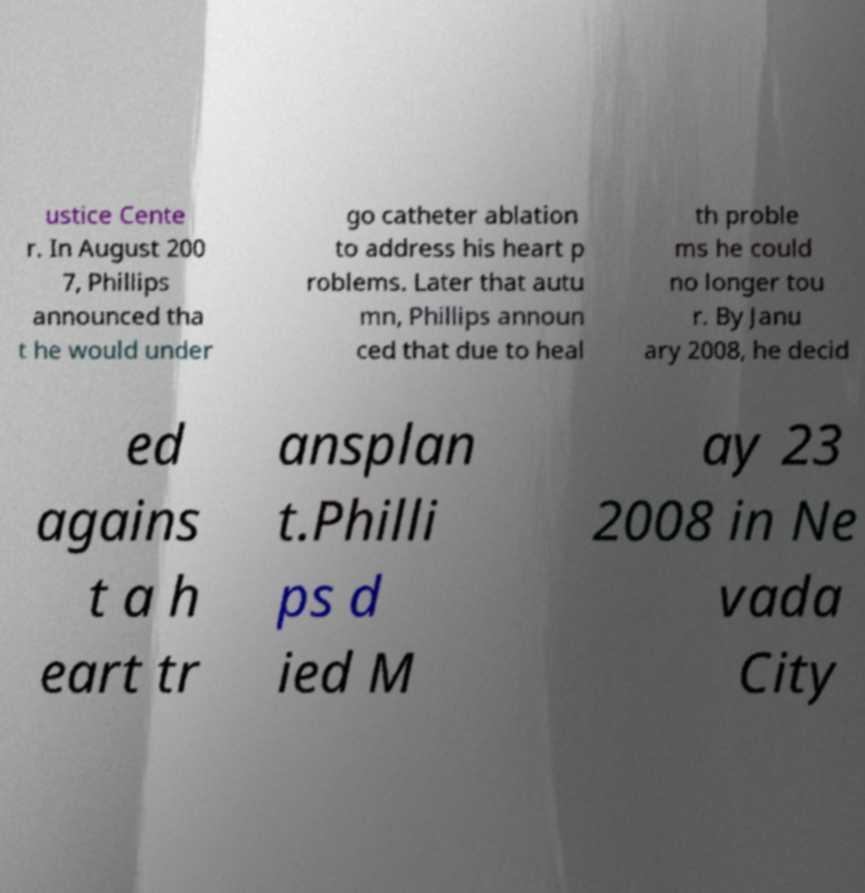There's text embedded in this image that I need extracted. Can you transcribe it verbatim? ustice Cente r. In August 200 7, Phillips announced tha t he would under go catheter ablation to address his heart p roblems. Later that autu mn, Phillips announ ced that due to heal th proble ms he could no longer tou r. By Janu ary 2008, he decid ed agains t a h eart tr ansplan t.Philli ps d ied M ay 23 2008 in Ne vada City 